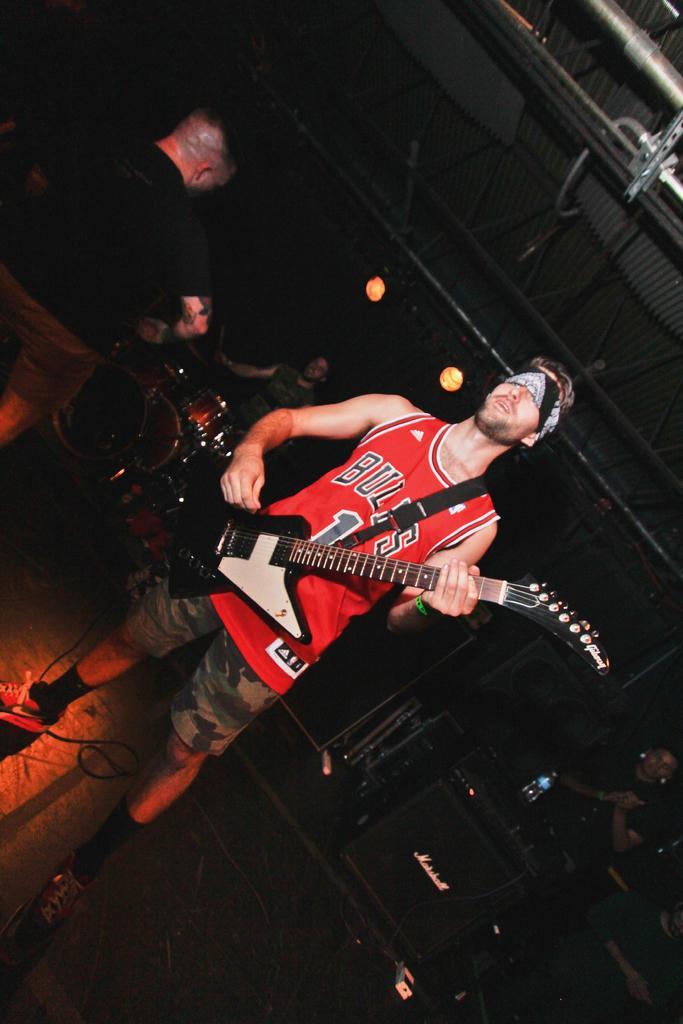How would you summarize this image in a sentence or two? There is a person holding a guitar and playing. And he is having a headband. In the back a person is playing drums. On the left side there is another person. In the back there are some instruments and some people are standing. 